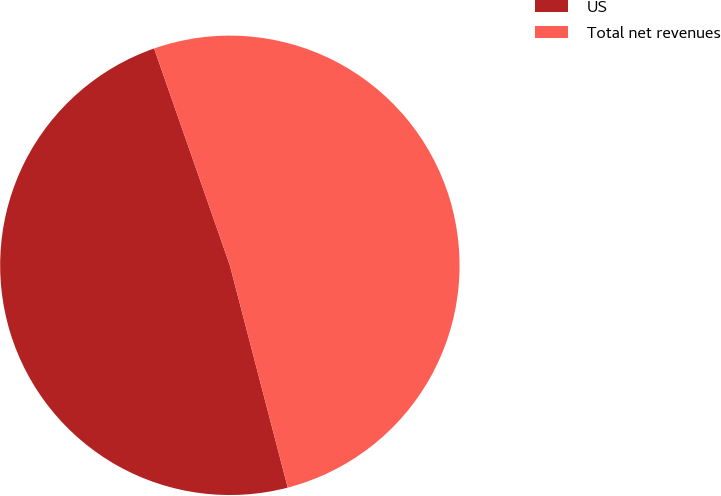<chart> <loc_0><loc_0><loc_500><loc_500><pie_chart><fcel>US<fcel>Total net revenues<nl><fcel>48.71%<fcel>51.29%<nl></chart> 